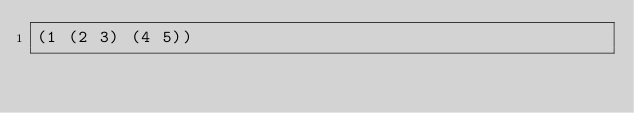<code> <loc_0><loc_0><loc_500><loc_500><_Lisp_>(1 (2 3) (4 5))
</code> 